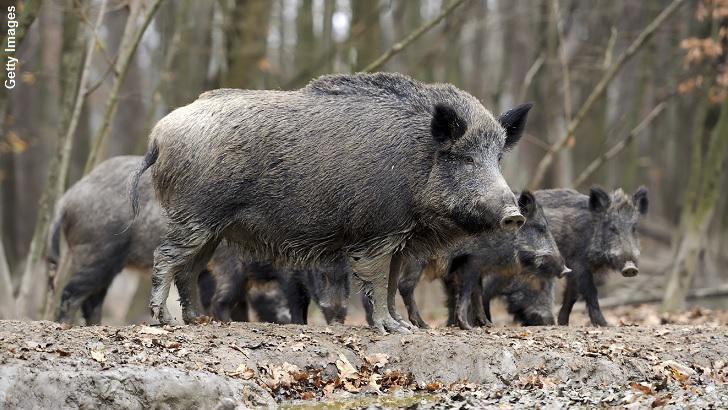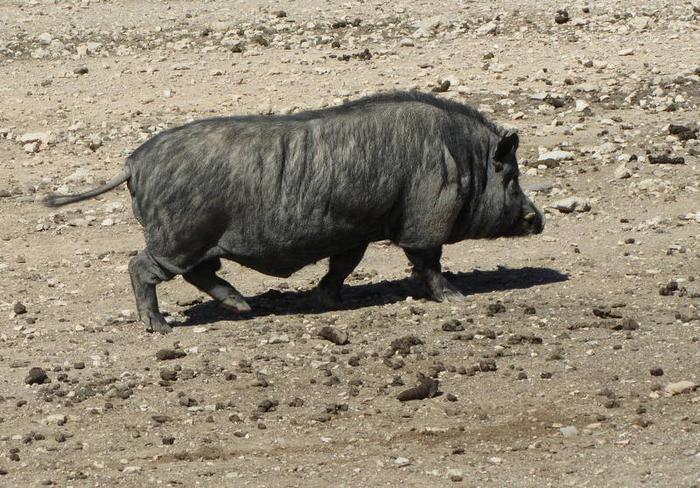The first image is the image on the left, the second image is the image on the right. For the images shown, is this caption "Three adult wild pigs stand in green grass with at least one baby pig whose hair has distinctive stripes." true? Answer yes or no. No. The first image is the image on the left, the second image is the image on the right. For the images displayed, is the sentence "The right image contains exactly one boar." factually correct? Answer yes or no. Yes. 